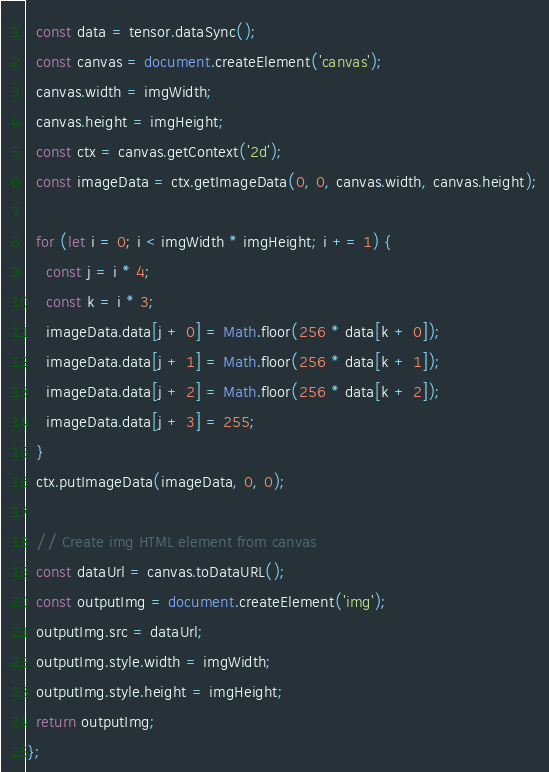Convert code to text. <code><loc_0><loc_0><loc_500><loc_500><_JavaScript_>  const data = tensor.dataSync();
  const canvas = document.createElement('canvas');
  canvas.width = imgWidth;
  canvas.height = imgHeight;
  const ctx = canvas.getContext('2d');
  const imageData = ctx.getImageData(0, 0, canvas.width, canvas.height);

  for (let i = 0; i < imgWidth * imgHeight; i += 1) {
    const j = i * 4;
    const k = i * 3;
    imageData.data[j + 0] = Math.floor(256 * data[k + 0]);
    imageData.data[j + 1] = Math.floor(256 * data[k + 1]);
    imageData.data[j + 2] = Math.floor(256 * data[k + 2]);
    imageData.data[j + 3] = 255;
  }
  ctx.putImageData(imageData, 0, 0);

  // Create img HTML element from canvas
  const dataUrl = canvas.toDataURL();
  const outputImg = document.createElement('img');
  outputImg.src = dataUrl;
  outputImg.style.width = imgWidth;
  outputImg.style.height = imgHeight;
  return outputImg;
};
</code> 